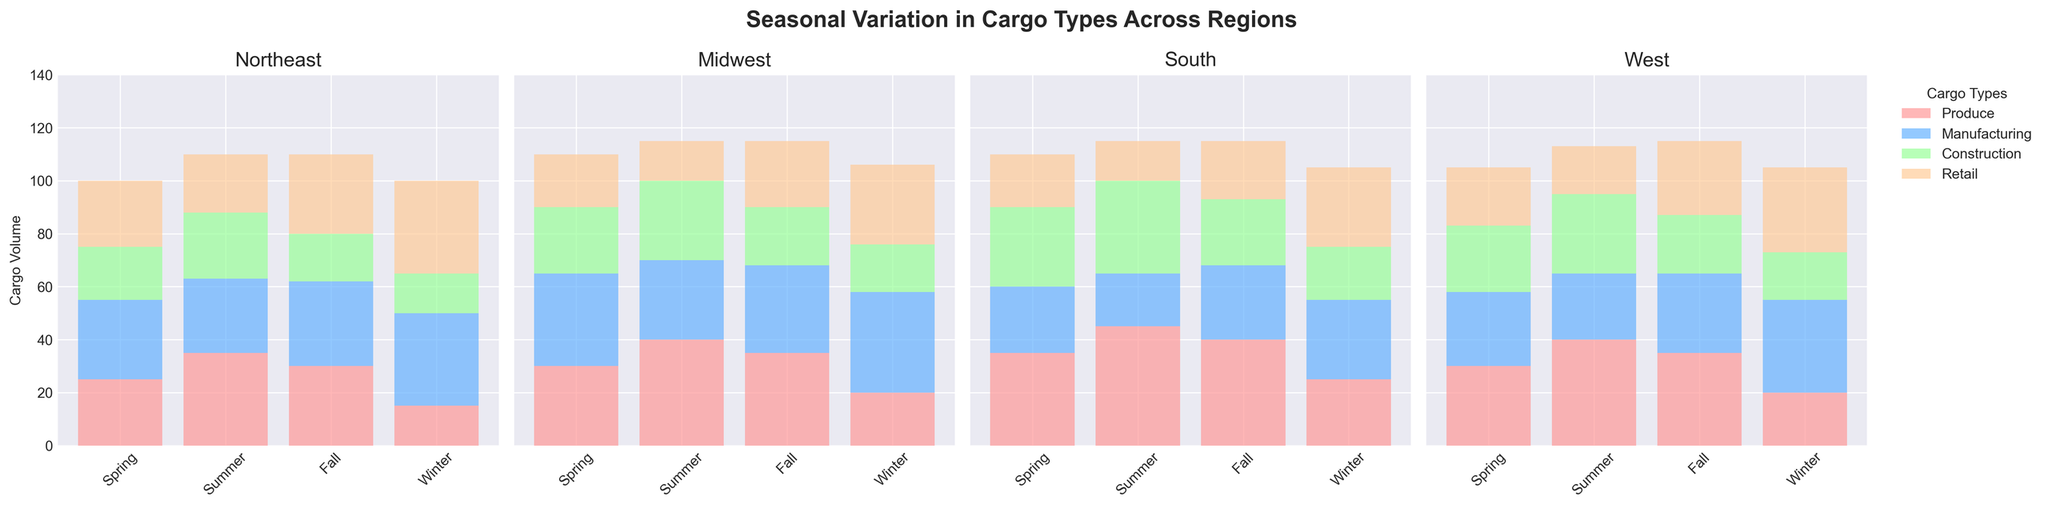Which region transports the highest volume of Produce during the summer? By looking at the summer bars for Produce in each subplot, the South region has the tallest bar for Produce during the summer.
Answer: South Which season has the highest combined volume of Manufacturing cargo across all regions? Sum the Manufacturing cargo volume for each season across all regions. Spring: 30+35+25+28=118, Summer: 28+30+20+25=103, Fall: 32+33+28+30=123, Winter: 35+38+30+35=138. Winter has the highest combined Manufacturing volume.
Answer: Winter What is the total cargo volume for Construction in the Midwest across all seasons? Add the cargo volumes for Construction in the Midwest across all seasons. Spring: 25, Summer: 30, Fall: 22, Winter: 18. Total = 25+30+22+18=95.
Answer: 95 Which region shows the greatest variation in Retail cargo volume across seasons? Identify the region with the largest difference between maximum and minimum Retail cargo volumes across seasons. Northeast: max 35, min 22, difference 13. Midwest: max 30, min 15, difference 15. South: max 30, min 15, difference 15. West: max 30, min 18, difference 12. Midwest and South both have a maximum difference.
Answer: Midwest and South Does Produce cargo in the Northeast region increase or decrease from spring to summer? Compare the height of the Produce cargo bar in the Northeast region between Spring and Summer. The bar height increases from 25 in Spring to 35 in Summer.
Answer: Increase In which region and season is the volume of Construction cargo the highest? Look at all the bars for Construction cargo across regions and seasons. The tallest bar is in the South region during the summer, with a volume of 35.
Answer: South, Summer What is the average volume of Retail cargo transported in the West region across all seasons? Sum all the Retail cargo volumes for the West region and divide by 4 (number of seasons). Retail: 22+18+28+32. Total = 100. Average = 100/4.
Answer: 25 Which cargo type has the most uniform distribution across seasons in the South region? Compare the bar heights for each cargo type in the South region across seasons to find the most uniform distribution. Construction bars are relatively consistent: 30, 35, 25, 20, indicating a more uniform distribution.
Answer: Construction 